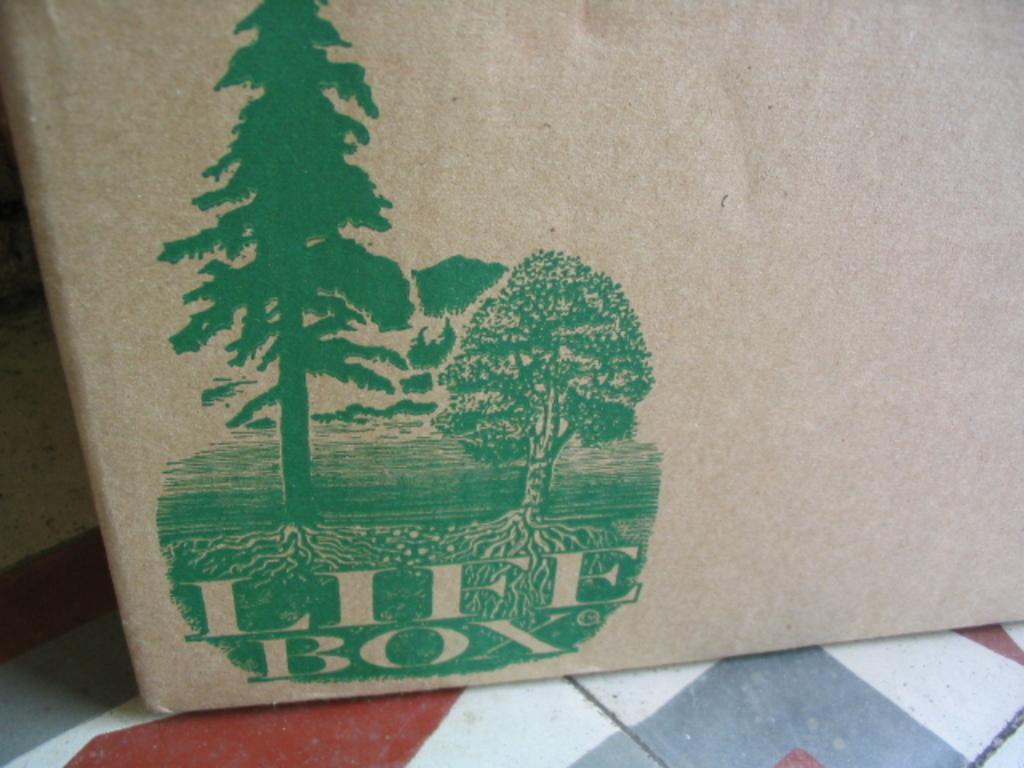<image>
Share a concise interpretation of the image provided. A package sitting on a chair from Life Box with a green tree on it. 